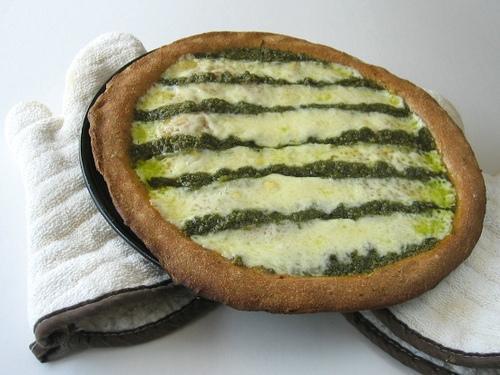How many oven mitts are there?
Give a very brief answer. 2. How many pizzas are there?
Give a very brief answer. 1. 